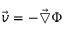Convert formula to latex. <formula><loc_0><loc_0><loc_500><loc_500>\vec { v } = - \vec { \bigtriangledown } \Phi</formula> 